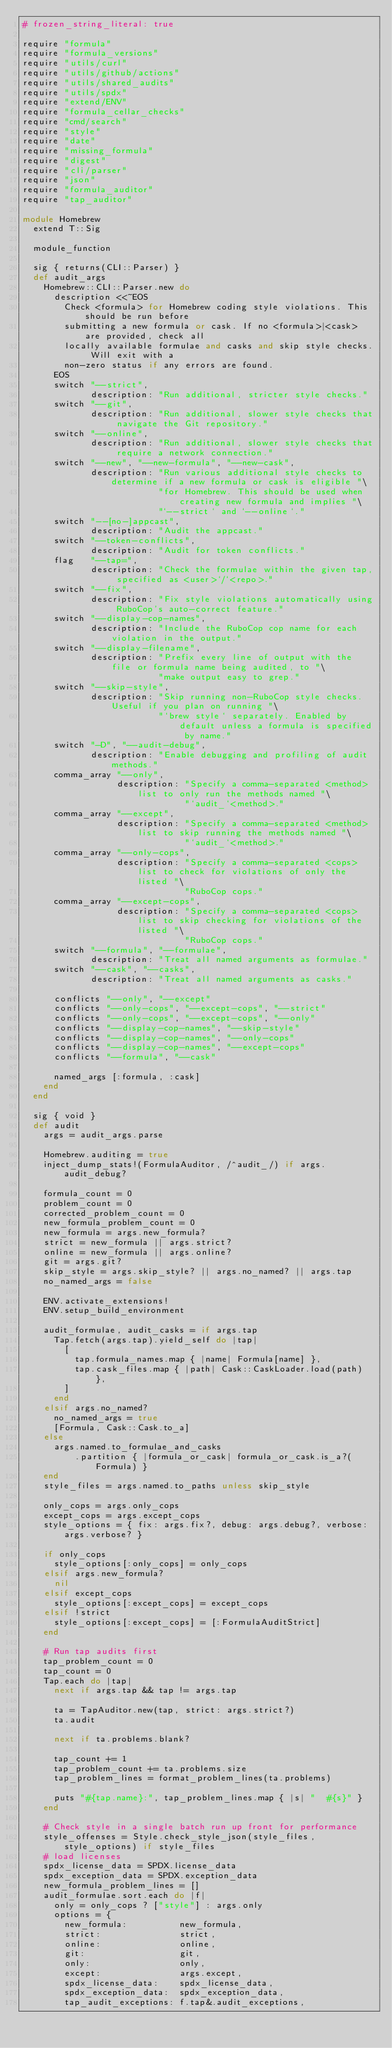Convert code to text. <code><loc_0><loc_0><loc_500><loc_500><_Ruby_># frozen_string_literal: true

require "formula"
require "formula_versions"
require "utils/curl"
require "utils/github/actions"
require "utils/shared_audits"
require "utils/spdx"
require "extend/ENV"
require "formula_cellar_checks"
require "cmd/search"
require "style"
require "date"
require "missing_formula"
require "digest"
require "cli/parser"
require "json"
require "formula_auditor"
require "tap_auditor"

module Homebrew
  extend T::Sig

  module_function

  sig { returns(CLI::Parser) }
  def audit_args
    Homebrew::CLI::Parser.new do
      description <<~EOS
        Check <formula> for Homebrew coding style violations. This should be run before
        submitting a new formula or cask. If no <formula>|<cask> are provided, check all
        locally available formulae and casks and skip style checks. Will exit with a
        non-zero status if any errors are found.
      EOS
      switch "--strict",
             description: "Run additional, stricter style checks."
      switch "--git",
             description: "Run additional, slower style checks that navigate the Git repository."
      switch "--online",
             description: "Run additional, slower style checks that require a network connection."
      switch "--new", "--new-formula", "--new-cask",
             description: "Run various additional style checks to determine if a new formula or cask is eligible "\
                          "for Homebrew. This should be used when creating new formula and implies "\
                          "`--strict` and `--online`."
      switch "--[no-]appcast",
             description: "Audit the appcast."
      switch "--token-conflicts",
             description: "Audit for token conflicts."
      flag   "--tap=",
             description: "Check the formulae within the given tap, specified as <user>`/`<repo>."
      switch "--fix",
             description: "Fix style violations automatically using RuboCop's auto-correct feature."
      switch "--display-cop-names",
             description: "Include the RuboCop cop name for each violation in the output."
      switch "--display-filename",
             description: "Prefix every line of output with the file or formula name being audited, to "\
                          "make output easy to grep."
      switch "--skip-style",
             description: "Skip running non-RuboCop style checks. Useful if you plan on running "\
                          "`brew style` separately. Enabled by default unless a formula is specified by name."
      switch "-D", "--audit-debug",
             description: "Enable debugging and profiling of audit methods."
      comma_array "--only",
                  description: "Specify a comma-separated <method> list to only run the methods named "\
                               "`audit_`<method>."
      comma_array "--except",
                  description: "Specify a comma-separated <method> list to skip running the methods named "\
                               "`audit_`<method>."
      comma_array "--only-cops",
                  description: "Specify a comma-separated <cops> list to check for violations of only the listed "\
                               "RuboCop cops."
      comma_array "--except-cops",
                  description: "Specify a comma-separated <cops> list to skip checking for violations of the listed "\
                               "RuboCop cops."
      switch "--formula", "--formulae",
             description: "Treat all named arguments as formulae."
      switch "--cask", "--casks",
             description: "Treat all named arguments as casks."

      conflicts "--only", "--except"
      conflicts "--only-cops", "--except-cops", "--strict"
      conflicts "--only-cops", "--except-cops", "--only"
      conflicts "--display-cop-names", "--skip-style"
      conflicts "--display-cop-names", "--only-cops"
      conflicts "--display-cop-names", "--except-cops"
      conflicts "--formula", "--cask"

      named_args [:formula, :cask]
    end
  end

  sig { void }
  def audit
    args = audit_args.parse

    Homebrew.auditing = true
    inject_dump_stats!(FormulaAuditor, /^audit_/) if args.audit_debug?

    formula_count = 0
    problem_count = 0
    corrected_problem_count = 0
    new_formula_problem_count = 0
    new_formula = args.new_formula?
    strict = new_formula || args.strict?
    online = new_formula || args.online?
    git = args.git?
    skip_style = args.skip_style? || args.no_named? || args.tap
    no_named_args = false

    ENV.activate_extensions!
    ENV.setup_build_environment

    audit_formulae, audit_casks = if args.tap
      Tap.fetch(args.tap).yield_self do |tap|
        [
          tap.formula_names.map { |name| Formula[name] },
          tap.cask_files.map { |path| Cask::CaskLoader.load(path) },
        ]
      end
    elsif args.no_named?
      no_named_args = true
      [Formula, Cask::Cask.to_a]
    else
      args.named.to_formulae_and_casks
          .partition { |formula_or_cask| formula_or_cask.is_a?(Formula) }
    end
    style_files = args.named.to_paths unless skip_style

    only_cops = args.only_cops
    except_cops = args.except_cops
    style_options = { fix: args.fix?, debug: args.debug?, verbose: args.verbose? }

    if only_cops
      style_options[:only_cops] = only_cops
    elsif args.new_formula?
      nil
    elsif except_cops
      style_options[:except_cops] = except_cops
    elsif !strict
      style_options[:except_cops] = [:FormulaAuditStrict]
    end

    # Run tap audits first
    tap_problem_count = 0
    tap_count = 0
    Tap.each do |tap|
      next if args.tap && tap != args.tap

      ta = TapAuditor.new(tap, strict: args.strict?)
      ta.audit

      next if ta.problems.blank?

      tap_count += 1
      tap_problem_count += ta.problems.size
      tap_problem_lines = format_problem_lines(ta.problems)

      puts "#{tap.name}:", tap_problem_lines.map { |s| "  #{s}" }
    end

    # Check style in a single batch run up front for performance
    style_offenses = Style.check_style_json(style_files, style_options) if style_files
    # load licenses
    spdx_license_data = SPDX.license_data
    spdx_exception_data = SPDX.exception_data
    new_formula_problem_lines = []
    audit_formulae.sort.each do |f|
      only = only_cops ? ["style"] : args.only
      options = {
        new_formula:          new_formula,
        strict:               strict,
        online:               online,
        git:                  git,
        only:                 only,
        except:               args.except,
        spdx_license_data:    spdx_license_data,
        spdx_exception_data:  spdx_exception_data,
        tap_audit_exceptions: f.tap&.audit_exceptions,</code> 